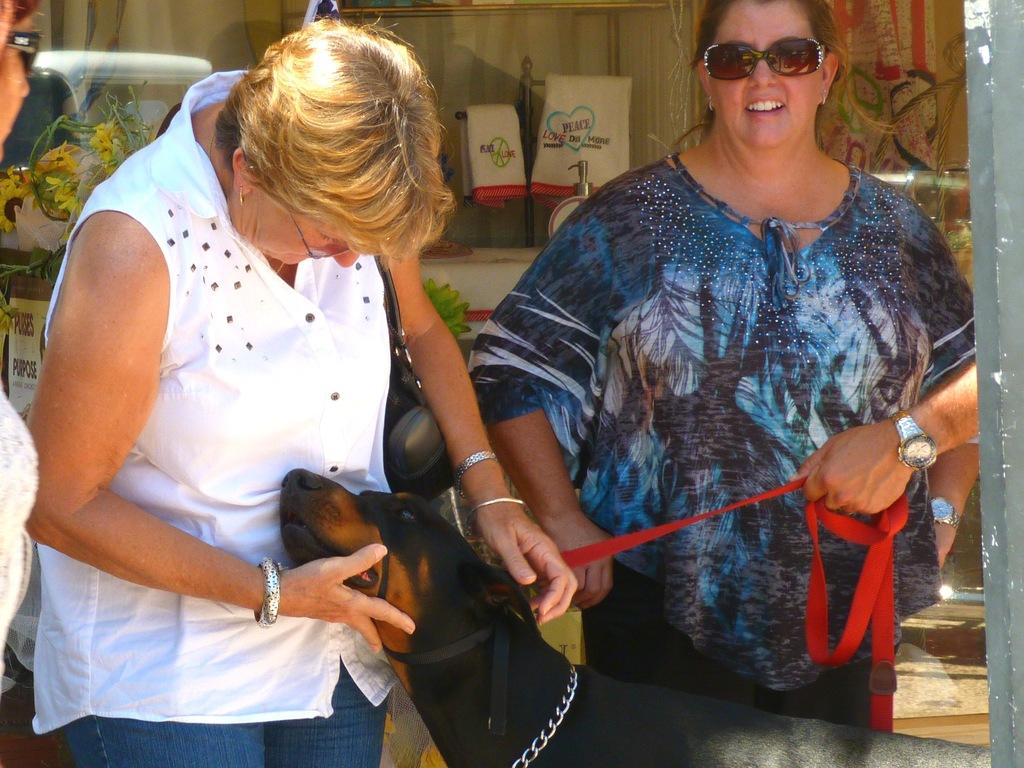How many women are present in the image? There are two women in the image. What are the women doing in the image? The women are standing. Can you identify any other living creature in the image? Yes, there is a dog in the image. What type of slope can be seen in the image? There is no slope present in the image. What reward is the dog receiving in the image? There is no indication in the image that the dog is receiving any reward. 